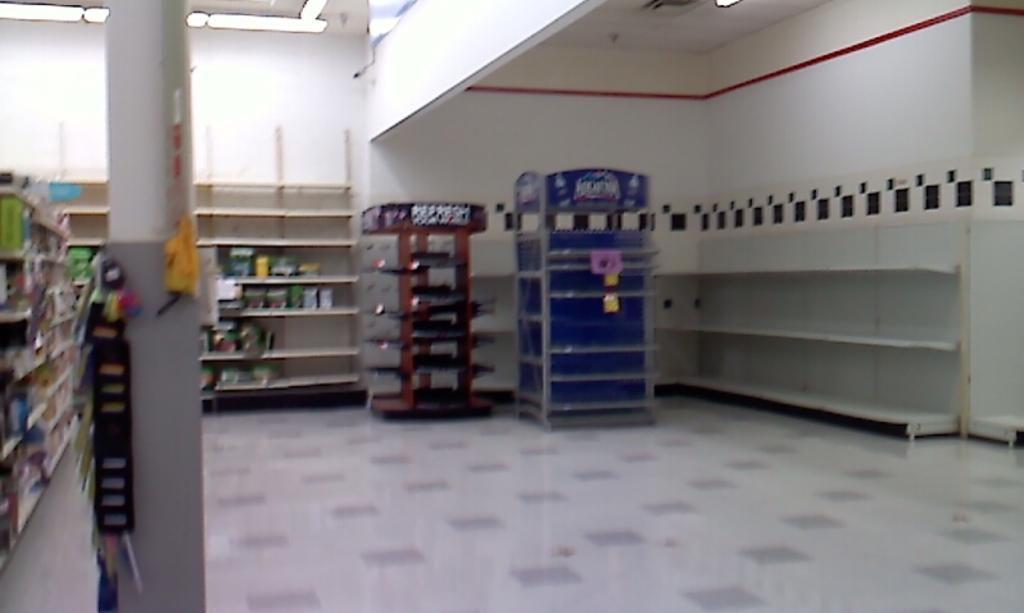<image>
Describe the image concisely. An open area of retail store with an empty Aquafina display case in the back corner. 